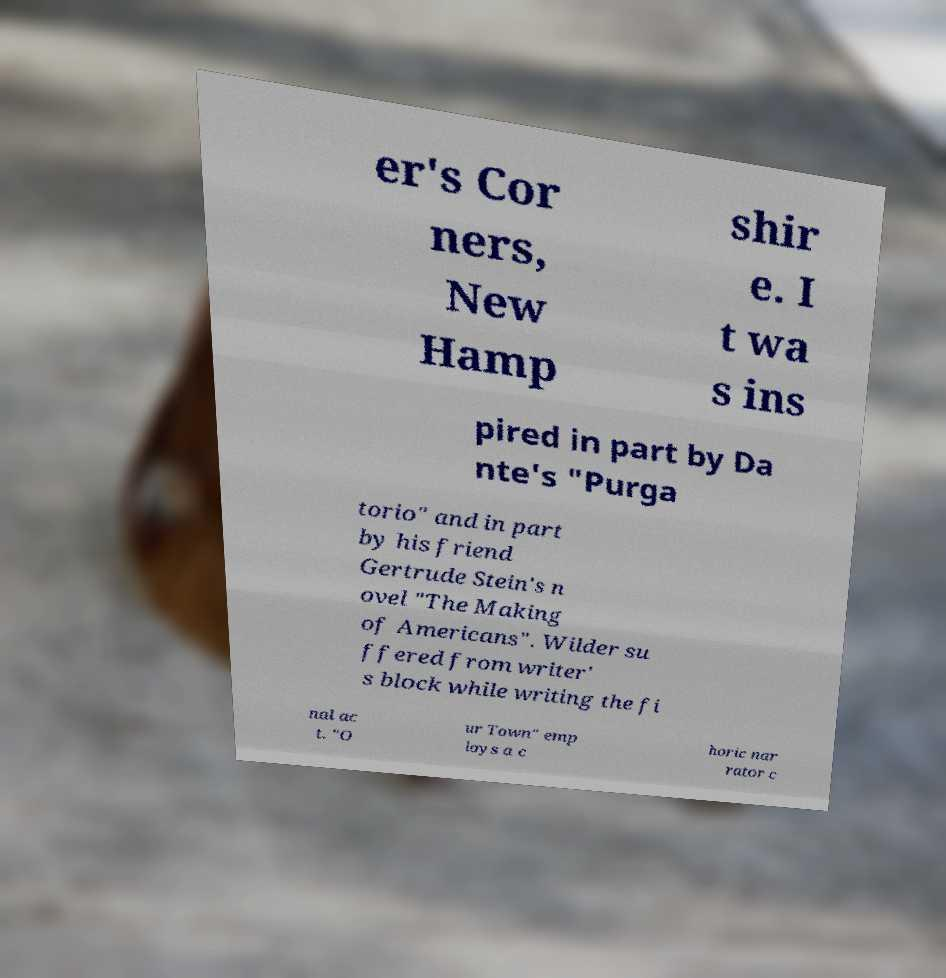Can you accurately transcribe the text from the provided image for me? er's Cor ners, New Hamp shir e. I t wa s ins pired in part by Da nte's "Purga torio" and in part by his friend Gertrude Stein's n ovel "The Making of Americans". Wilder su ffered from writer' s block while writing the fi nal ac t. "O ur Town" emp loys a c horic nar rator c 